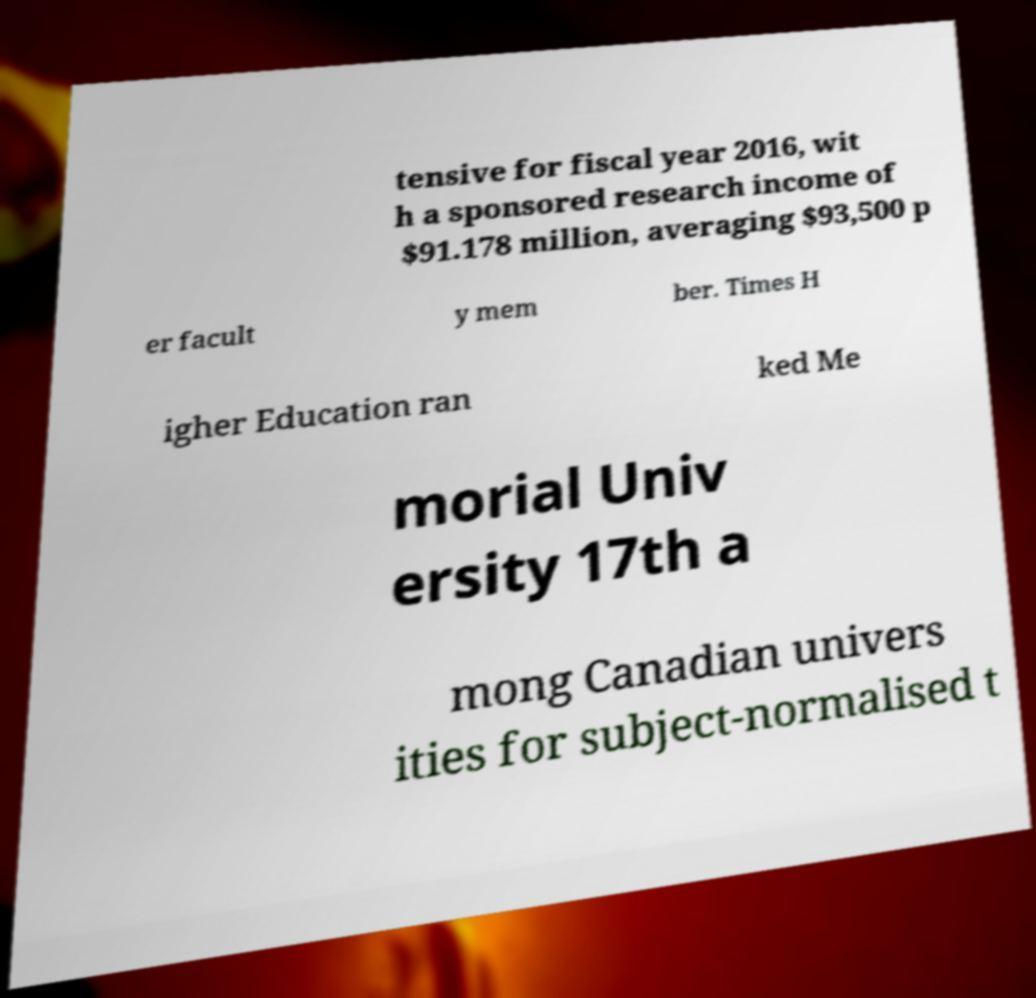Could you assist in decoding the text presented in this image and type it out clearly? tensive for fiscal year 2016, wit h a sponsored research income of $91.178 million, averaging $93,500 p er facult y mem ber. Times H igher Education ran ked Me morial Univ ersity 17th a mong Canadian univers ities for subject-normalised t 